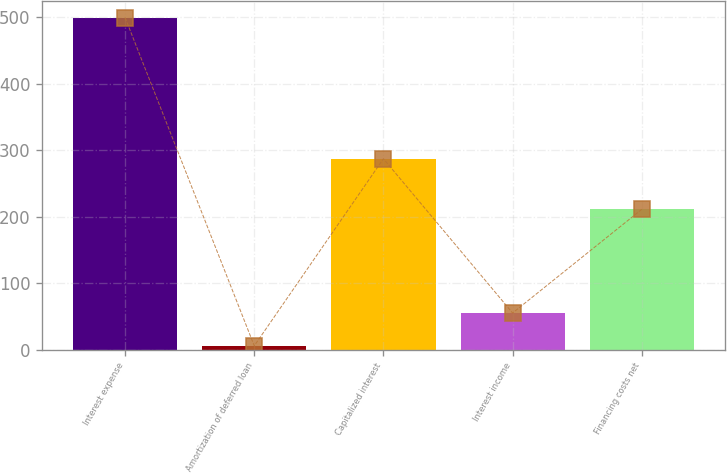<chart> <loc_0><loc_0><loc_500><loc_500><bar_chart><fcel>Interest expense<fcel>Amortization of deferred loan<fcel>Capitalized interest<fcel>Interest income<fcel>Financing costs net<nl><fcel>499<fcel>6<fcel>287<fcel>55.3<fcel>211<nl></chart> 